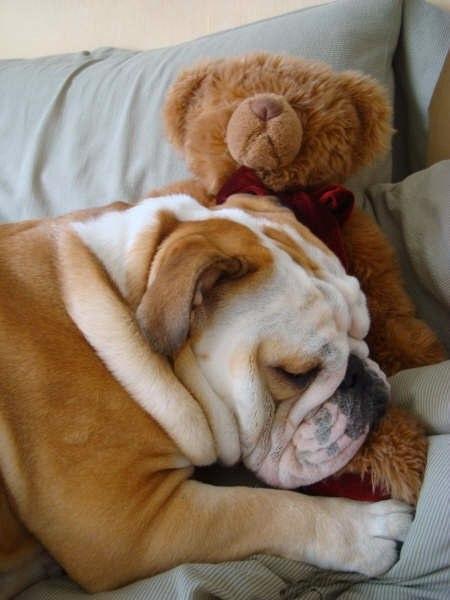Is the given caption "The couch is beneath the teddy bear." fitting for the image?
Answer yes or no. Yes. Does the caption "The teddy bear is at the left side of the couch." correctly depict the image?
Answer yes or no. No. 